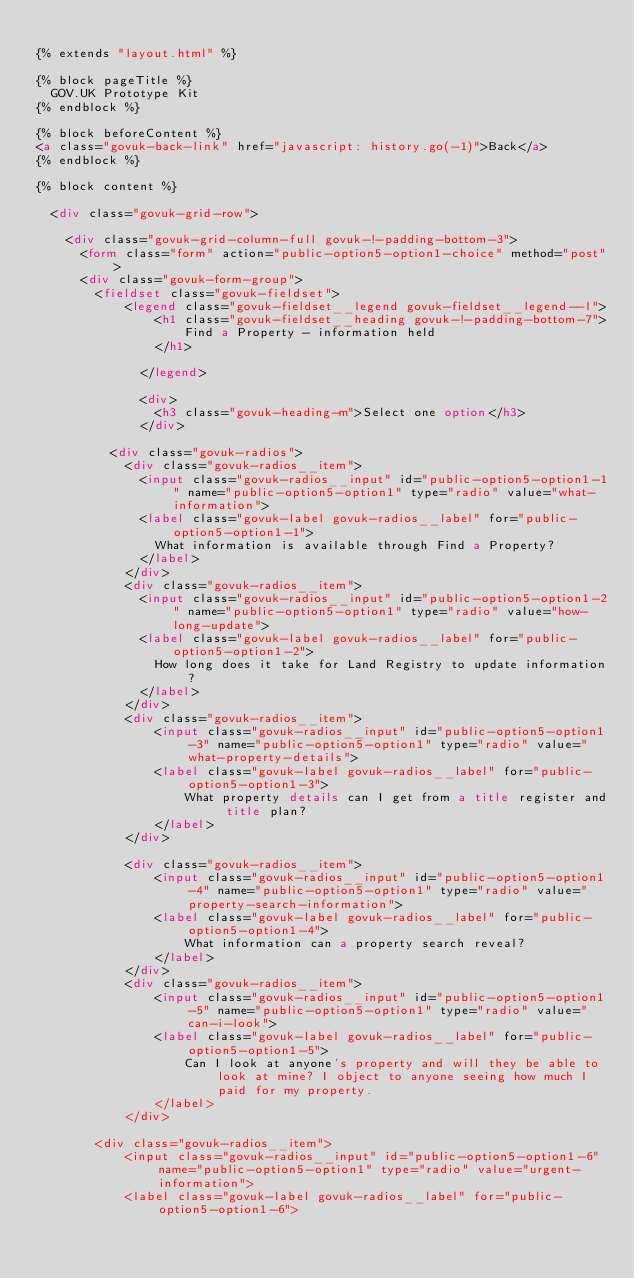<code> <loc_0><loc_0><loc_500><loc_500><_HTML_>
{% extends "layout.html" %}

{% block pageTitle %}
  GOV.UK Prototype Kit
{% endblock %}

{% block beforeContent %}
<a class="govuk-back-link" href="javascript: history.go(-1)">Back</a>
{% endblock %}

{% block content %}

  <div class="govuk-grid-row">

    <div class="govuk-grid-column-full govuk-!-padding-bottom-3">
      <form class="form" action="public-option5-option1-choice" method="post">
      <div class="govuk-form-group">
        <fieldset class="govuk-fieldset">
            <legend class="govuk-fieldset__legend govuk-fieldset__legend--l">
                <h1 class="govuk-fieldset__heading govuk-!-padding-bottom-7">
                    Find a Property - information held
                </h1>
                
              </legend>

              <div>
                <h3 class="govuk-heading-m">Select one option</h3>
              </div>

          <div class="govuk-radios">
            <div class="govuk-radios__item">
              <input class="govuk-radios__input" id="public-option5-option1-1" name="public-option5-option1" type="radio" value="what-information">
              <label class="govuk-label govuk-radios__label" for="public-option5-option1-1">
                What information is available through Find a Property?
              </label>
            </div>
            <div class="govuk-radios__item">
              <input class="govuk-radios__input" id="public-option5-option1-2" name="public-option5-option1" type="radio" value="how-long-update">
              <label class="govuk-label govuk-radios__label" for="public-option5-option1-2">
                How long does it take for Land Registry to update information?
              </label>
            </div>
            <div class="govuk-radios__item">
                <input class="govuk-radios__input" id="public-option5-option1-3" name="public-option5-option1" type="radio" value="what-property-details">
                <label class="govuk-label govuk-radios__label" for="public-option5-option1-3">
                    What property details can I get from a title register and title plan?
                </label>
            </div>

            <div class="govuk-radios__item">
                <input class="govuk-radios__input" id="public-option5-option1-4" name="public-option5-option1" type="radio" value="property-search-information">
                <label class="govuk-label govuk-radios__label" for="public-option5-option1-4">
                    What information can a property search reveal?
                </label>
            </div>
            <div class="govuk-radios__item">
                <input class="govuk-radios__input" id="public-option5-option1-5" name="public-option5-option1" type="radio" value="can-i-look">
                <label class="govuk-label govuk-radios__label" for="public-option5-option1-5">
                    Can I look at anyone's property and will they be able to look at mine? I object to anyone seeing how much I paid for my property.
                </label>
            </div>
        
        <div class="govuk-radios__item">
            <input class="govuk-radios__input" id="public-option5-option1-6" name="public-option5-option1" type="radio" value="urgent-information">
            <label class="govuk-label govuk-radios__label" for="public-option5-option1-6"></code> 